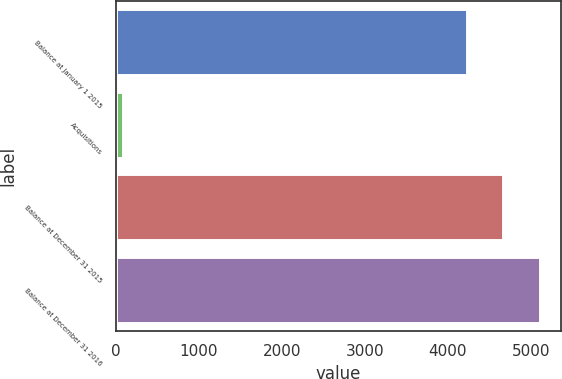<chart> <loc_0><loc_0><loc_500><loc_500><bar_chart><fcel>Balance at January 1 2015<fcel>Acquisitions<fcel>Balance at December 31 2015<fcel>Balance at December 31 2016<nl><fcel>4236<fcel>89<fcel>4672<fcel>5108<nl></chart> 